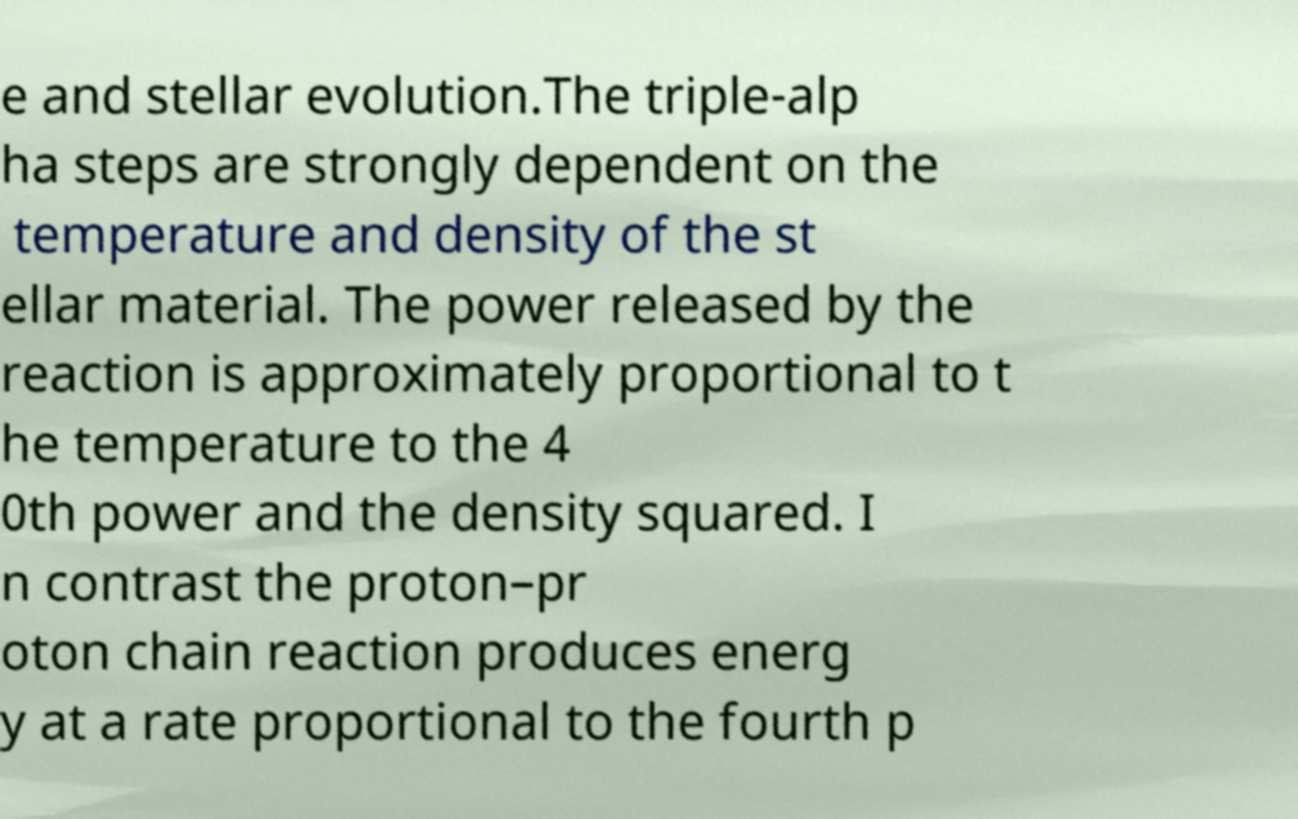What messages or text are displayed in this image? I need them in a readable, typed format. e and stellar evolution.The triple-alp ha steps are strongly dependent on the temperature and density of the st ellar material. The power released by the reaction is approximately proportional to t he temperature to the 4 0th power and the density squared. I n contrast the proton–pr oton chain reaction produces energ y at a rate proportional to the fourth p 